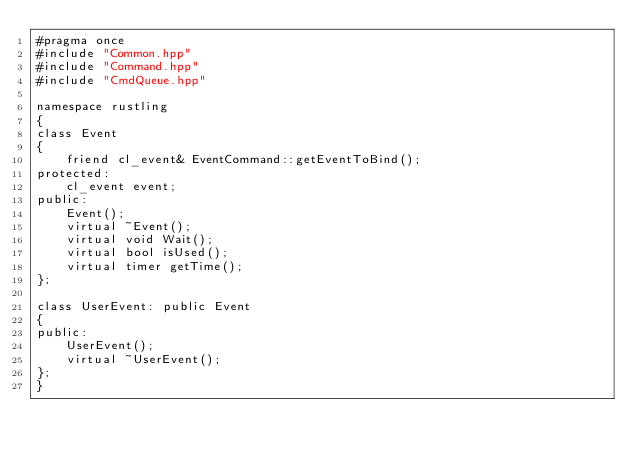<code> <loc_0><loc_0><loc_500><loc_500><_C++_>#pragma once
#include "Common.hpp"
#include "Command.hpp"
#include "CmdQueue.hpp"

namespace rustling
{
class Event
{
    friend cl_event& EventCommand::getEventToBind();
protected:
    cl_event event;
public:
    Event();
    virtual ~Event();
    virtual void Wait();
    virtual bool isUsed();
    virtual timer getTime();
};

class UserEvent: public Event
{
public:
    UserEvent();
    virtual ~UserEvent();
};
}
</code> 